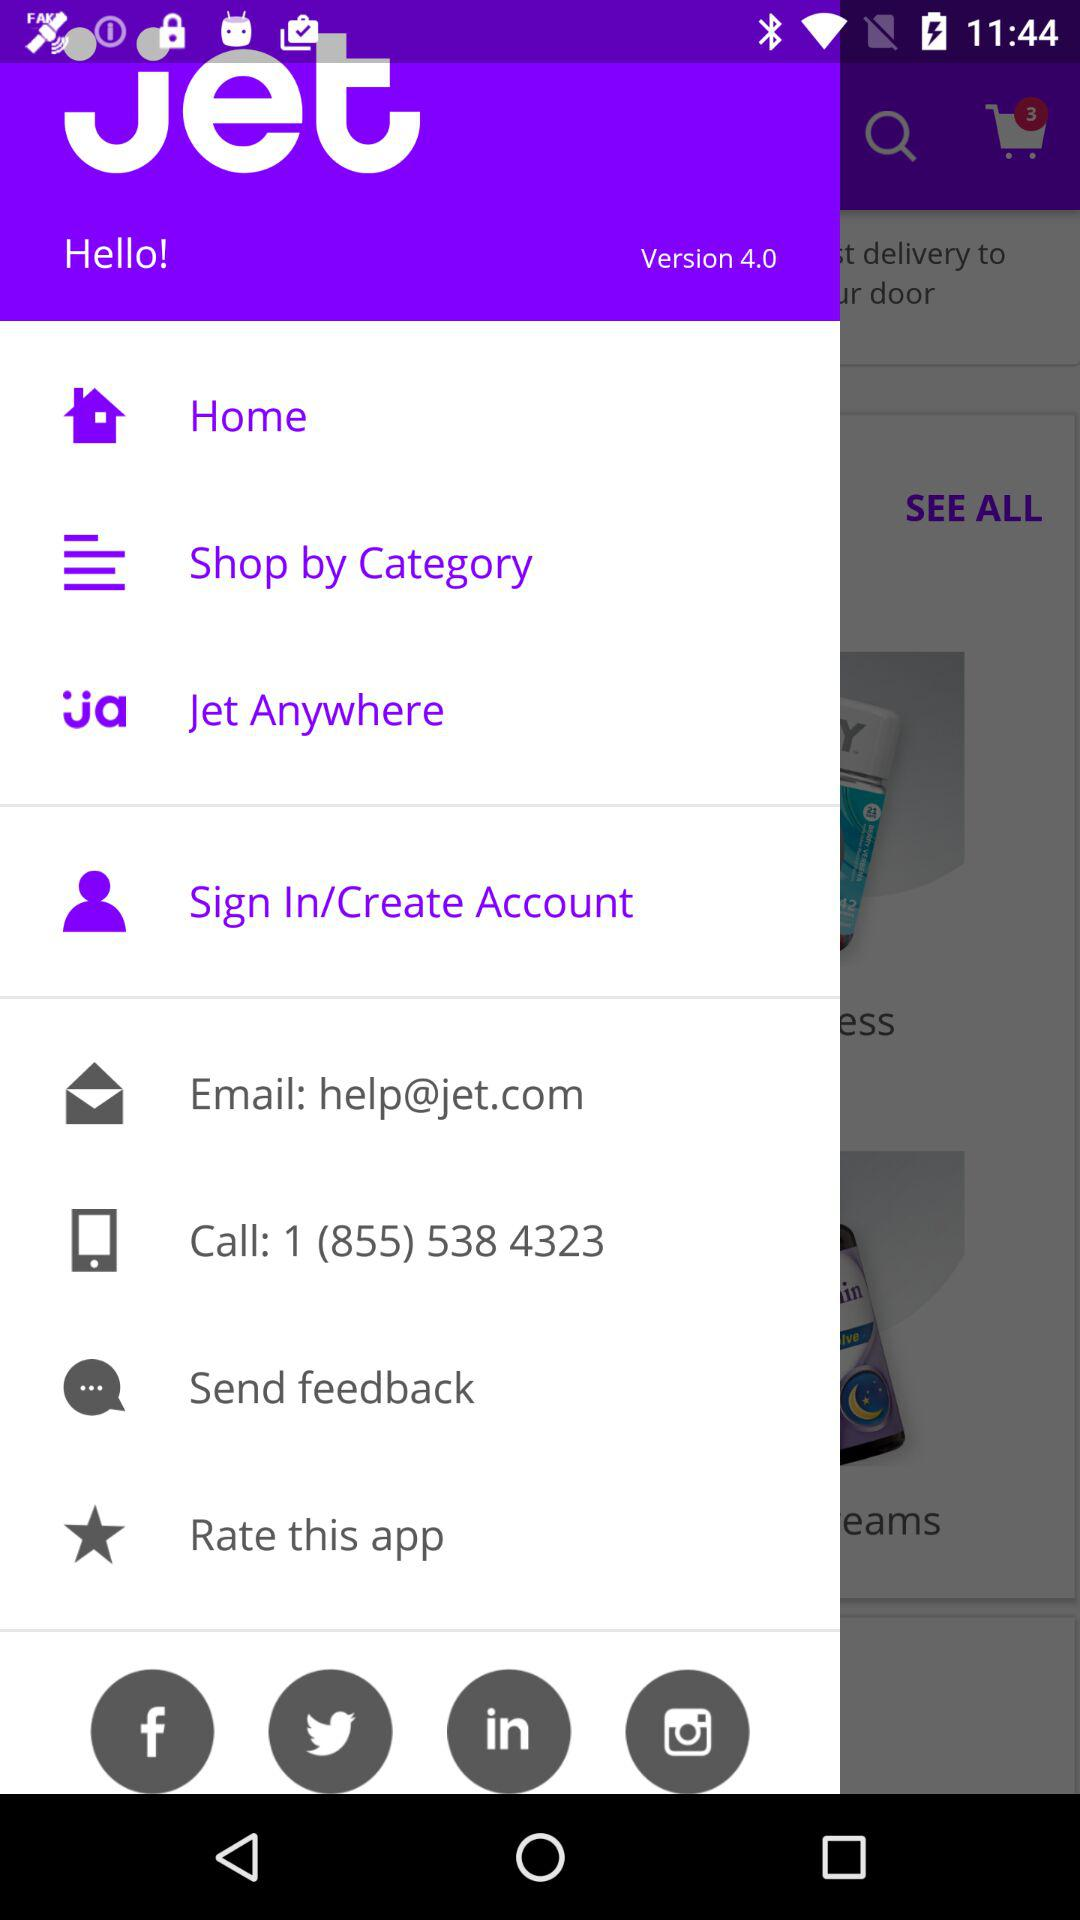Which version is it? The version is 4.0. 